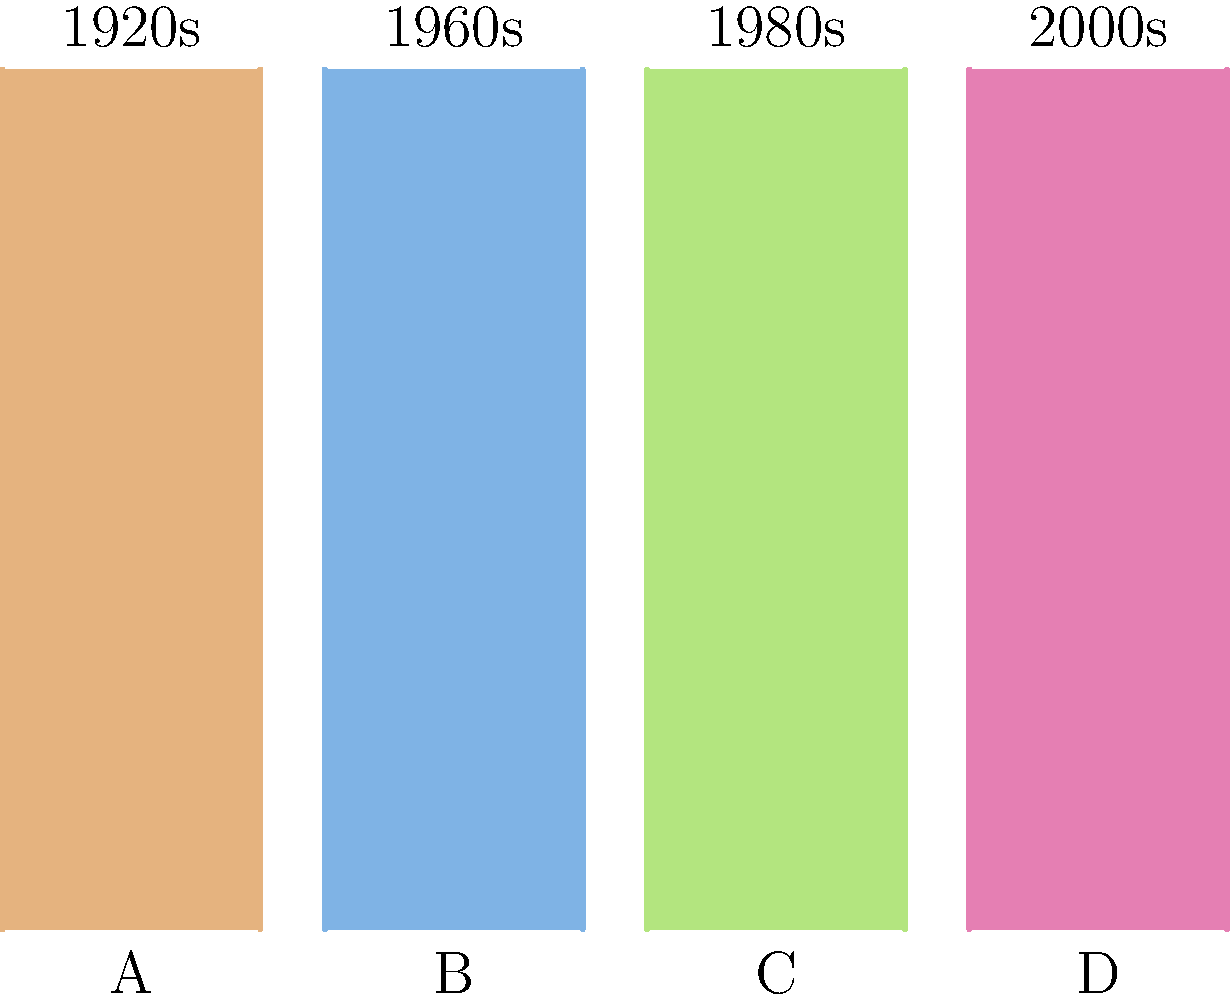Match the film strip transitions (A, B, C, D) to their corresponding historical time periods (1920s, 1960s, 1980s, 2000s) based on the visual style and color palette typically associated with films from these eras. To match the film strip transitions to their corresponding historical time periods, we need to consider the visual style and color palette typically associated with films from these eras:

1. Strip A (Sepia tone): This warm, brownish tint is characteristic of early films from the 1920s. The lack of full color represents the limitations of film technology at that time.

2. Strip B (Muted blue tones): This color palette is often associated with films from the 1960s, representing a shift towards more experimental and artistic color grading techniques.

3. Strip C (Vibrant greens and yellows): This color scheme is typical of 1980s films, which often featured bold, saturated colors reflecting the era's aesthetic.

4. Strip D (High contrast pinks and purples): This color palette is representative of films from the 2000s, showcasing the advanced color grading capabilities of modern digital cinema.

By analyzing the visual characteristics of each strip and matching them to the typical aesthetics of each era, we can determine the correct pairing of film strips to historical time periods.
Answer: A-1920s, B-1960s, C-1980s, D-2000s 